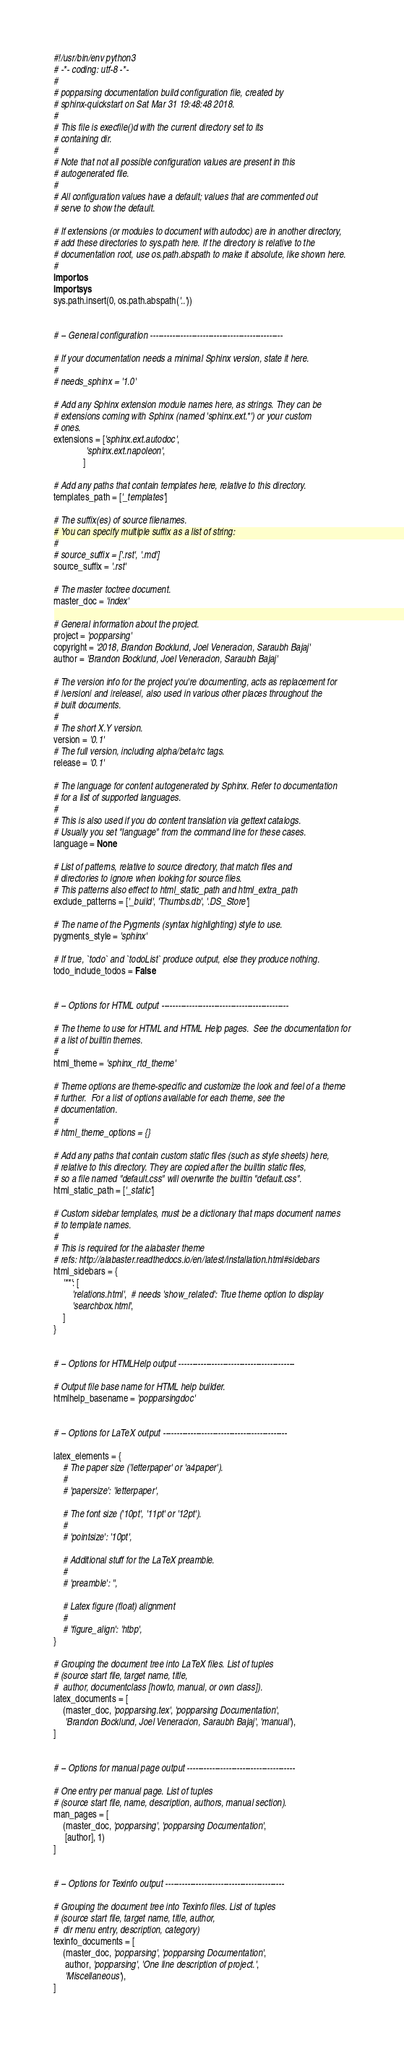Convert code to text. <code><loc_0><loc_0><loc_500><loc_500><_Python_>#!/usr/bin/env python3
# -*- coding: utf-8 -*-
#
# popparsing documentation build configuration file, created by
# sphinx-quickstart on Sat Mar 31 19:48:48 2018.
#
# This file is execfile()d with the current directory set to its
# containing dir.
#
# Note that not all possible configuration values are present in this
# autogenerated file.
#
# All configuration values have a default; values that are commented out
# serve to show the default.

# If extensions (or modules to document with autodoc) are in another directory,
# add these directories to sys.path here. If the directory is relative to the
# documentation root, use os.path.abspath to make it absolute, like shown here.
#
import os
import sys
sys.path.insert(0, os.path.abspath('..'))


# -- General configuration ------------------------------------------------

# If your documentation needs a minimal Sphinx version, state it here.
#
# needs_sphinx = '1.0'

# Add any Sphinx extension module names here, as strings. They can be
# extensions coming with Sphinx (named 'sphinx.ext.*') or your custom
# ones.
extensions = ['sphinx.ext.autodoc',
              'sphinx.ext.napoleon',
             ]

# Add any paths that contain templates here, relative to this directory.
templates_path = ['_templates']

# The suffix(es) of source filenames.
# You can specify multiple suffix as a list of string:
#
# source_suffix = ['.rst', '.md']
source_suffix = '.rst'

# The master toctree document.
master_doc = 'index'

# General information about the project.
project = 'popparsing'
copyright = '2018, Brandon Bocklund, Joel Veneracion, Saraubh Bajaj'
author = 'Brandon Bocklund, Joel Veneracion, Saraubh Bajaj'

# The version info for the project you're documenting, acts as replacement for
# |version| and |release|, also used in various other places throughout the
# built documents.
#
# The short X.Y version.
version = '0.1'
# The full version, including alpha/beta/rc tags.
release = '0.1'

# The language for content autogenerated by Sphinx. Refer to documentation
# for a list of supported languages.
#
# This is also used if you do content translation via gettext catalogs.
# Usually you set "language" from the command line for these cases.
language = None

# List of patterns, relative to source directory, that match files and
# directories to ignore when looking for source files.
# This patterns also effect to html_static_path and html_extra_path
exclude_patterns = ['_build', 'Thumbs.db', '.DS_Store']

# The name of the Pygments (syntax highlighting) style to use.
pygments_style = 'sphinx'

# If true, `todo` and `todoList` produce output, else they produce nothing.
todo_include_todos = False


# -- Options for HTML output ----------------------------------------------

# The theme to use for HTML and HTML Help pages.  See the documentation for
# a list of builtin themes.
#
html_theme = 'sphinx_rtd_theme'

# Theme options are theme-specific and customize the look and feel of a theme
# further.  For a list of options available for each theme, see the
# documentation.
#
# html_theme_options = {}

# Add any paths that contain custom static files (such as style sheets) here,
# relative to this directory. They are copied after the builtin static files,
# so a file named "default.css" will overwrite the builtin "default.css".
html_static_path = ['_static']

# Custom sidebar templates, must be a dictionary that maps document names
# to template names.
#
# This is required for the alabaster theme
# refs: http://alabaster.readthedocs.io/en/latest/installation.html#sidebars
html_sidebars = {
    '**': [
        'relations.html',  # needs 'show_related': True theme option to display
        'searchbox.html',
    ]
}


# -- Options for HTMLHelp output ------------------------------------------

# Output file base name for HTML help builder.
htmlhelp_basename = 'popparsingdoc'


# -- Options for LaTeX output ---------------------------------------------

latex_elements = {
    # The paper size ('letterpaper' or 'a4paper').
    #
    # 'papersize': 'letterpaper',

    # The font size ('10pt', '11pt' or '12pt').
    #
    # 'pointsize': '10pt',

    # Additional stuff for the LaTeX preamble.
    #
    # 'preamble': '',

    # Latex figure (float) alignment
    #
    # 'figure_align': 'htbp',
}

# Grouping the document tree into LaTeX files. List of tuples
# (source start file, target name, title,
#  author, documentclass [howto, manual, or own class]).
latex_documents = [
    (master_doc, 'popparsing.tex', 'popparsing Documentation',
     'Brandon Bocklund, Joel Veneracion, Saraubh Bajaj', 'manual'),
]


# -- Options for manual page output ---------------------------------------

# One entry per manual page. List of tuples
# (source start file, name, description, authors, manual section).
man_pages = [
    (master_doc, 'popparsing', 'popparsing Documentation',
     [author], 1)
]


# -- Options for Texinfo output -------------------------------------------

# Grouping the document tree into Texinfo files. List of tuples
# (source start file, target name, title, author,
#  dir menu entry, description, category)
texinfo_documents = [
    (master_doc, 'popparsing', 'popparsing Documentation',
     author, 'popparsing', 'One line description of project.',
     'Miscellaneous'),
]



</code> 